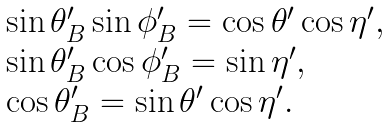Convert formula to latex. <formula><loc_0><loc_0><loc_500><loc_500>\begin{array} { l } \sin \theta ^ { \prime } _ { B } \sin \phi ^ { \prime } _ { B } = \cos \theta ^ { \prime } \cos \eta ^ { \prime } , \\ \sin \theta ^ { \prime } _ { B } \cos \phi ^ { \prime } _ { B } = \sin \eta ^ { \prime } , \\ \cos \theta ^ { \prime } _ { B } = \sin \theta ^ { \prime } \cos \eta ^ { \prime } . \end{array}</formula> 